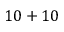<formula> <loc_0><loc_0><loc_500><loc_500>1 0 + 1 0</formula> 